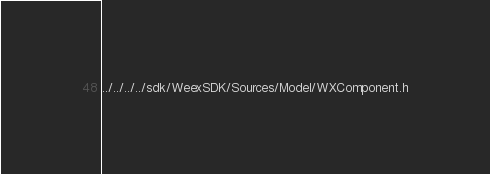Convert code to text. <code><loc_0><loc_0><loc_500><loc_500><_C_>../../../../sdk/WeexSDK/Sources/Model/WXComponent.h</code> 